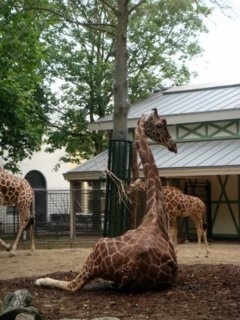Describe the objects in this image and their specific colors. I can see giraffe in darkgreen, black, maroon, and gray tones, giraffe in darkgreen, gray, maroon, and black tones, and giraffe in darkgreen, maroon, gray, and black tones in this image. 